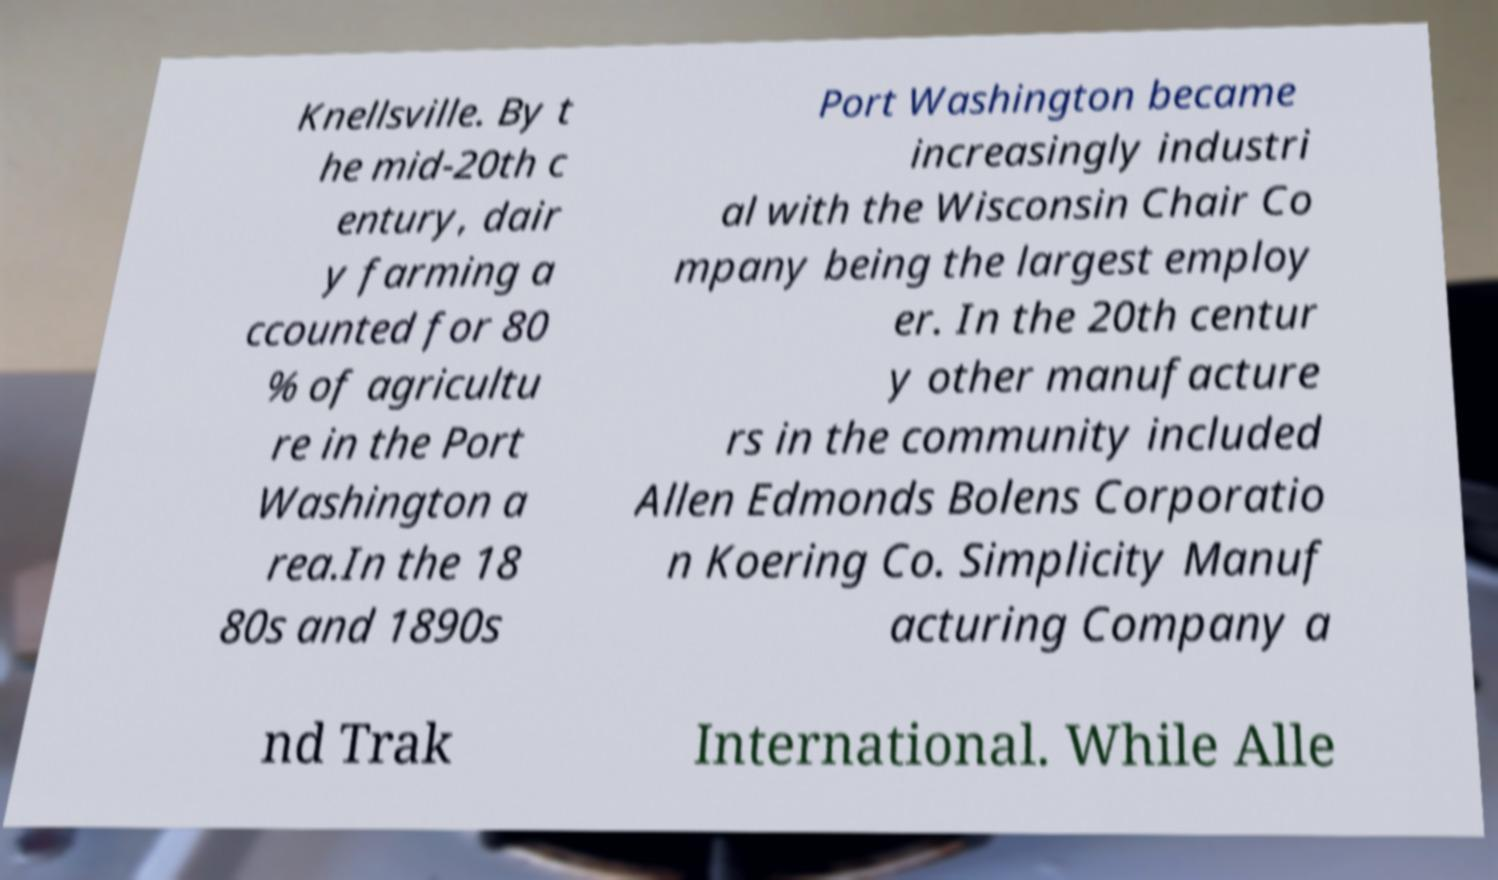Can you accurately transcribe the text from the provided image for me? Knellsville. By t he mid-20th c entury, dair y farming a ccounted for 80 % of agricultu re in the Port Washington a rea.In the 18 80s and 1890s Port Washington became increasingly industri al with the Wisconsin Chair Co mpany being the largest employ er. In the 20th centur y other manufacture rs in the community included Allen Edmonds Bolens Corporatio n Koering Co. Simplicity Manuf acturing Company a nd Trak International. While Alle 